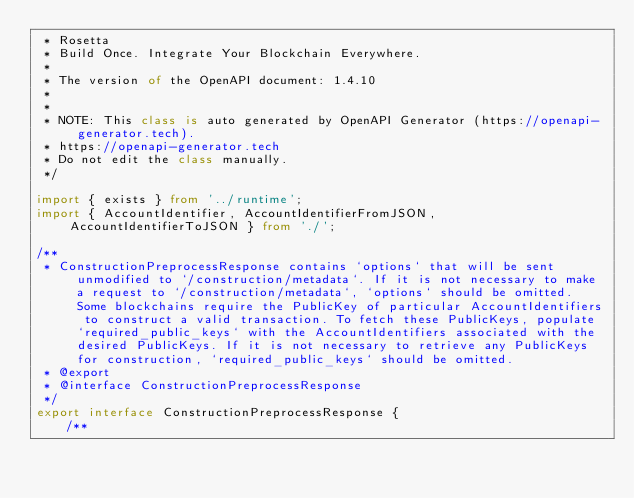<code> <loc_0><loc_0><loc_500><loc_500><_TypeScript_> * Rosetta
 * Build Once. Integrate Your Blockchain Everywhere.
 *
 * The version of the OpenAPI document: 1.4.10
 *
 *
 * NOTE: This class is auto generated by OpenAPI Generator (https://openapi-generator.tech).
 * https://openapi-generator.tech
 * Do not edit the class manually.
 */

import { exists } from '../runtime';
import { AccountIdentifier, AccountIdentifierFromJSON, AccountIdentifierToJSON } from './';

/**
 * ConstructionPreprocessResponse contains `options` that will be sent unmodified to `/construction/metadata`. If it is not necessary to make a request to `/construction/metadata`, `options` should be omitted.  Some blockchains require the PublicKey of particular AccountIdentifiers to construct a valid transaction. To fetch these PublicKeys, populate `required_public_keys` with the AccountIdentifiers associated with the desired PublicKeys. If it is not necessary to retrieve any PublicKeys for construction, `required_public_keys` should be omitted.
 * @export
 * @interface ConstructionPreprocessResponse
 */
export interface ConstructionPreprocessResponse {
    /**</code> 